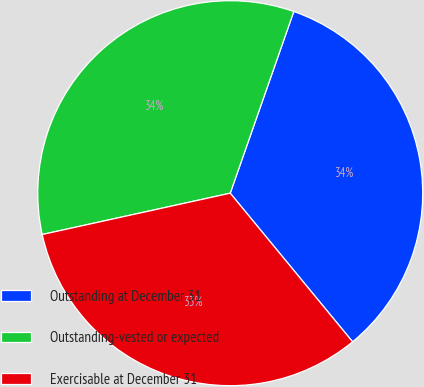<chart> <loc_0><loc_0><loc_500><loc_500><pie_chart><fcel>Outstanding at December 31<fcel>Outstanding-vested or expected<fcel>Exercisable at December 31<nl><fcel>33.68%<fcel>33.8%<fcel>32.52%<nl></chart> 